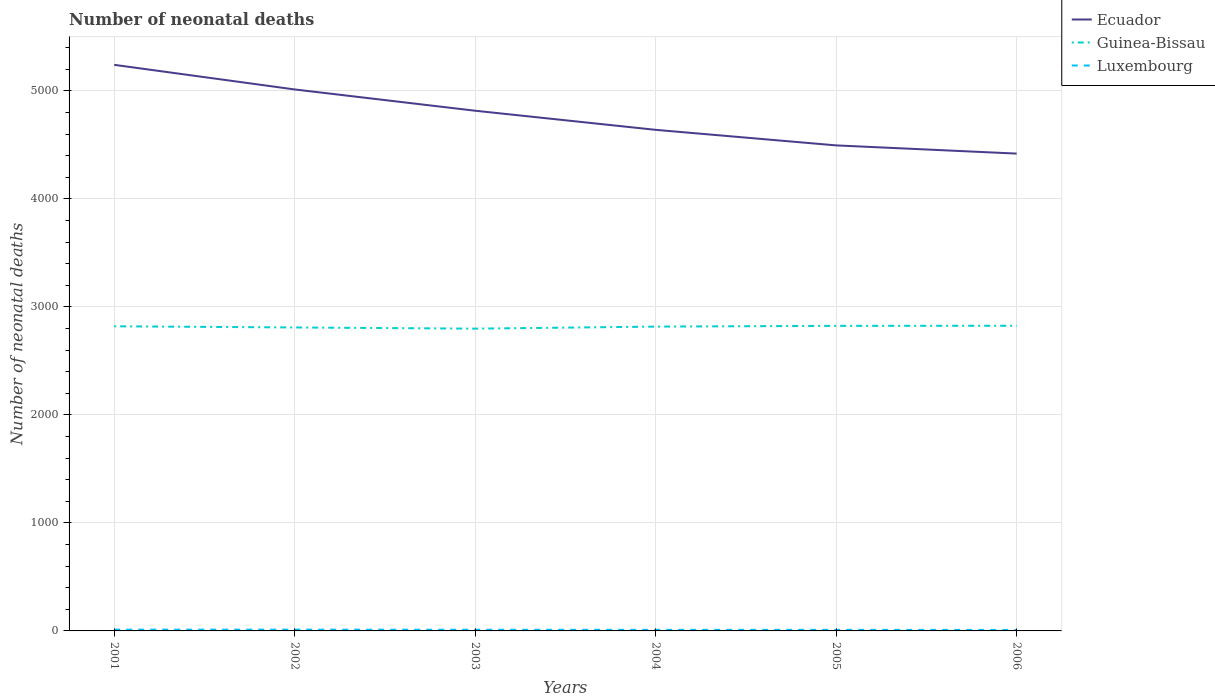Across all years, what is the maximum number of neonatal deaths in in Guinea-Bissau?
Keep it short and to the point. 2799. What is the total number of neonatal deaths in in Guinea-Bissau in the graph?
Your response must be concise. 3. What is the difference between the highest and the second highest number of neonatal deaths in in Guinea-Bissau?
Keep it short and to the point. 27. What is the difference between the highest and the lowest number of neonatal deaths in in Ecuador?
Your answer should be compact. 3. How many years are there in the graph?
Your answer should be compact. 6. What is the difference between two consecutive major ticks on the Y-axis?
Provide a succinct answer. 1000. Does the graph contain grids?
Provide a succinct answer. Yes. How many legend labels are there?
Provide a short and direct response. 3. How are the legend labels stacked?
Provide a succinct answer. Vertical. What is the title of the graph?
Your answer should be very brief. Number of neonatal deaths. What is the label or title of the X-axis?
Ensure brevity in your answer.  Years. What is the label or title of the Y-axis?
Your answer should be compact. Number of neonatal deaths. What is the Number of neonatal deaths in Ecuador in 2001?
Offer a very short reply. 5242. What is the Number of neonatal deaths in Guinea-Bissau in 2001?
Your answer should be very brief. 2821. What is the Number of neonatal deaths in Luxembourg in 2001?
Your response must be concise. 12. What is the Number of neonatal deaths of Ecuador in 2002?
Provide a short and direct response. 5014. What is the Number of neonatal deaths of Guinea-Bissau in 2002?
Provide a short and direct response. 2810. What is the Number of neonatal deaths of Ecuador in 2003?
Keep it short and to the point. 4817. What is the Number of neonatal deaths of Guinea-Bissau in 2003?
Keep it short and to the point. 2799. What is the Number of neonatal deaths of Luxembourg in 2003?
Keep it short and to the point. 11. What is the Number of neonatal deaths in Ecuador in 2004?
Your answer should be compact. 4640. What is the Number of neonatal deaths in Guinea-Bissau in 2004?
Keep it short and to the point. 2818. What is the Number of neonatal deaths of Luxembourg in 2004?
Provide a short and direct response. 10. What is the Number of neonatal deaths in Ecuador in 2005?
Provide a succinct answer. 4496. What is the Number of neonatal deaths in Guinea-Bissau in 2005?
Give a very brief answer. 2825. What is the Number of neonatal deaths in Luxembourg in 2005?
Offer a very short reply. 10. What is the Number of neonatal deaths of Ecuador in 2006?
Keep it short and to the point. 4420. What is the Number of neonatal deaths in Guinea-Bissau in 2006?
Give a very brief answer. 2826. What is the Number of neonatal deaths of Luxembourg in 2006?
Offer a terse response. 9. Across all years, what is the maximum Number of neonatal deaths in Ecuador?
Give a very brief answer. 5242. Across all years, what is the maximum Number of neonatal deaths in Guinea-Bissau?
Your response must be concise. 2826. Across all years, what is the maximum Number of neonatal deaths of Luxembourg?
Keep it short and to the point. 12. Across all years, what is the minimum Number of neonatal deaths in Ecuador?
Ensure brevity in your answer.  4420. Across all years, what is the minimum Number of neonatal deaths in Guinea-Bissau?
Your response must be concise. 2799. What is the total Number of neonatal deaths of Ecuador in the graph?
Provide a short and direct response. 2.86e+04. What is the total Number of neonatal deaths in Guinea-Bissau in the graph?
Make the answer very short. 1.69e+04. What is the difference between the Number of neonatal deaths in Ecuador in 2001 and that in 2002?
Offer a very short reply. 228. What is the difference between the Number of neonatal deaths in Guinea-Bissau in 2001 and that in 2002?
Your answer should be very brief. 11. What is the difference between the Number of neonatal deaths of Ecuador in 2001 and that in 2003?
Make the answer very short. 425. What is the difference between the Number of neonatal deaths in Guinea-Bissau in 2001 and that in 2003?
Offer a terse response. 22. What is the difference between the Number of neonatal deaths of Ecuador in 2001 and that in 2004?
Provide a succinct answer. 602. What is the difference between the Number of neonatal deaths of Guinea-Bissau in 2001 and that in 2004?
Your response must be concise. 3. What is the difference between the Number of neonatal deaths in Luxembourg in 2001 and that in 2004?
Offer a terse response. 2. What is the difference between the Number of neonatal deaths in Ecuador in 2001 and that in 2005?
Your response must be concise. 746. What is the difference between the Number of neonatal deaths of Luxembourg in 2001 and that in 2005?
Offer a terse response. 2. What is the difference between the Number of neonatal deaths of Ecuador in 2001 and that in 2006?
Ensure brevity in your answer.  822. What is the difference between the Number of neonatal deaths of Luxembourg in 2001 and that in 2006?
Make the answer very short. 3. What is the difference between the Number of neonatal deaths in Ecuador in 2002 and that in 2003?
Make the answer very short. 197. What is the difference between the Number of neonatal deaths in Guinea-Bissau in 2002 and that in 2003?
Give a very brief answer. 11. What is the difference between the Number of neonatal deaths of Luxembourg in 2002 and that in 2003?
Give a very brief answer. 1. What is the difference between the Number of neonatal deaths in Ecuador in 2002 and that in 2004?
Provide a succinct answer. 374. What is the difference between the Number of neonatal deaths in Ecuador in 2002 and that in 2005?
Your answer should be compact. 518. What is the difference between the Number of neonatal deaths in Guinea-Bissau in 2002 and that in 2005?
Keep it short and to the point. -15. What is the difference between the Number of neonatal deaths in Luxembourg in 2002 and that in 2005?
Your answer should be very brief. 2. What is the difference between the Number of neonatal deaths of Ecuador in 2002 and that in 2006?
Your answer should be very brief. 594. What is the difference between the Number of neonatal deaths in Ecuador in 2003 and that in 2004?
Your response must be concise. 177. What is the difference between the Number of neonatal deaths of Ecuador in 2003 and that in 2005?
Offer a terse response. 321. What is the difference between the Number of neonatal deaths of Guinea-Bissau in 2003 and that in 2005?
Make the answer very short. -26. What is the difference between the Number of neonatal deaths of Luxembourg in 2003 and that in 2005?
Your answer should be compact. 1. What is the difference between the Number of neonatal deaths of Ecuador in 2003 and that in 2006?
Your response must be concise. 397. What is the difference between the Number of neonatal deaths in Luxembourg in 2003 and that in 2006?
Provide a succinct answer. 2. What is the difference between the Number of neonatal deaths of Ecuador in 2004 and that in 2005?
Ensure brevity in your answer.  144. What is the difference between the Number of neonatal deaths in Luxembourg in 2004 and that in 2005?
Keep it short and to the point. 0. What is the difference between the Number of neonatal deaths of Ecuador in 2004 and that in 2006?
Provide a succinct answer. 220. What is the difference between the Number of neonatal deaths of Guinea-Bissau in 2005 and that in 2006?
Offer a very short reply. -1. What is the difference between the Number of neonatal deaths in Ecuador in 2001 and the Number of neonatal deaths in Guinea-Bissau in 2002?
Provide a short and direct response. 2432. What is the difference between the Number of neonatal deaths of Ecuador in 2001 and the Number of neonatal deaths of Luxembourg in 2002?
Your response must be concise. 5230. What is the difference between the Number of neonatal deaths of Guinea-Bissau in 2001 and the Number of neonatal deaths of Luxembourg in 2002?
Give a very brief answer. 2809. What is the difference between the Number of neonatal deaths of Ecuador in 2001 and the Number of neonatal deaths of Guinea-Bissau in 2003?
Make the answer very short. 2443. What is the difference between the Number of neonatal deaths in Ecuador in 2001 and the Number of neonatal deaths in Luxembourg in 2003?
Provide a short and direct response. 5231. What is the difference between the Number of neonatal deaths of Guinea-Bissau in 2001 and the Number of neonatal deaths of Luxembourg in 2003?
Give a very brief answer. 2810. What is the difference between the Number of neonatal deaths in Ecuador in 2001 and the Number of neonatal deaths in Guinea-Bissau in 2004?
Offer a very short reply. 2424. What is the difference between the Number of neonatal deaths of Ecuador in 2001 and the Number of neonatal deaths of Luxembourg in 2004?
Make the answer very short. 5232. What is the difference between the Number of neonatal deaths in Guinea-Bissau in 2001 and the Number of neonatal deaths in Luxembourg in 2004?
Ensure brevity in your answer.  2811. What is the difference between the Number of neonatal deaths in Ecuador in 2001 and the Number of neonatal deaths in Guinea-Bissau in 2005?
Your answer should be very brief. 2417. What is the difference between the Number of neonatal deaths in Ecuador in 2001 and the Number of neonatal deaths in Luxembourg in 2005?
Ensure brevity in your answer.  5232. What is the difference between the Number of neonatal deaths in Guinea-Bissau in 2001 and the Number of neonatal deaths in Luxembourg in 2005?
Your answer should be compact. 2811. What is the difference between the Number of neonatal deaths of Ecuador in 2001 and the Number of neonatal deaths of Guinea-Bissau in 2006?
Provide a short and direct response. 2416. What is the difference between the Number of neonatal deaths of Ecuador in 2001 and the Number of neonatal deaths of Luxembourg in 2006?
Your response must be concise. 5233. What is the difference between the Number of neonatal deaths in Guinea-Bissau in 2001 and the Number of neonatal deaths in Luxembourg in 2006?
Your response must be concise. 2812. What is the difference between the Number of neonatal deaths of Ecuador in 2002 and the Number of neonatal deaths of Guinea-Bissau in 2003?
Make the answer very short. 2215. What is the difference between the Number of neonatal deaths in Ecuador in 2002 and the Number of neonatal deaths in Luxembourg in 2003?
Your answer should be compact. 5003. What is the difference between the Number of neonatal deaths of Guinea-Bissau in 2002 and the Number of neonatal deaths of Luxembourg in 2003?
Make the answer very short. 2799. What is the difference between the Number of neonatal deaths in Ecuador in 2002 and the Number of neonatal deaths in Guinea-Bissau in 2004?
Your response must be concise. 2196. What is the difference between the Number of neonatal deaths of Ecuador in 2002 and the Number of neonatal deaths of Luxembourg in 2004?
Make the answer very short. 5004. What is the difference between the Number of neonatal deaths of Guinea-Bissau in 2002 and the Number of neonatal deaths of Luxembourg in 2004?
Ensure brevity in your answer.  2800. What is the difference between the Number of neonatal deaths of Ecuador in 2002 and the Number of neonatal deaths of Guinea-Bissau in 2005?
Provide a succinct answer. 2189. What is the difference between the Number of neonatal deaths of Ecuador in 2002 and the Number of neonatal deaths of Luxembourg in 2005?
Your answer should be compact. 5004. What is the difference between the Number of neonatal deaths in Guinea-Bissau in 2002 and the Number of neonatal deaths in Luxembourg in 2005?
Ensure brevity in your answer.  2800. What is the difference between the Number of neonatal deaths in Ecuador in 2002 and the Number of neonatal deaths in Guinea-Bissau in 2006?
Offer a terse response. 2188. What is the difference between the Number of neonatal deaths in Ecuador in 2002 and the Number of neonatal deaths in Luxembourg in 2006?
Provide a succinct answer. 5005. What is the difference between the Number of neonatal deaths of Guinea-Bissau in 2002 and the Number of neonatal deaths of Luxembourg in 2006?
Ensure brevity in your answer.  2801. What is the difference between the Number of neonatal deaths in Ecuador in 2003 and the Number of neonatal deaths in Guinea-Bissau in 2004?
Keep it short and to the point. 1999. What is the difference between the Number of neonatal deaths of Ecuador in 2003 and the Number of neonatal deaths of Luxembourg in 2004?
Make the answer very short. 4807. What is the difference between the Number of neonatal deaths in Guinea-Bissau in 2003 and the Number of neonatal deaths in Luxembourg in 2004?
Offer a terse response. 2789. What is the difference between the Number of neonatal deaths of Ecuador in 2003 and the Number of neonatal deaths of Guinea-Bissau in 2005?
Your response must be concise. 1992. What is the difference between the Number of neonatal deaths of Ecuador in 2003 and the Number of neonatal deaths of Luxembourg in 2005?
Provide a succinct answer. 4807. What is the difference between the Number of neonatal deaths in Guinea-Bissau in 2003 and the Number of neonatal deaths in Luxembourg in 2005?
Ensure brevity in your answer.  2789. What is the difference between the Number of neonatal deaths of Ecuador in 2003 and the Number of neonatal deaths of Guinea-Bissau in 2006?
Provide a succinct answer. 1991. What is the difference between the Number of neonatal deaths in Ecuador in 2003 and the Number of neonatal deaths in Luxembourg in 2006?
Your response must be concise. 4808. What is the difference between the Number of neonatal deaths in Guinea-Bissau in 2003 and the Number of neonatal deaths in Luxembourg in 2006?
Offer a very short reply. 2790. What is the difference between the Number of neonatal deaths in Ecuador in 2004 and the Number of neonatal deaths in Guinea-Bissau in 2005?
Your response must be concise. 1815. What is the difference between the Number of neonatal deaths of Ecuador in 2004 and the Number of neonatal deaths of Luxembourg in 2005?
Ensure brevity in your answer.  4630. What is the difference between the Number of neonatal deaths of Guinea-Bissau in 2004 and the Number of neonatal deaths of Luxembourg in 2005?
Give a very brief answer. 2808. What is the difference between the Number of neonatal deaths of Ecuador in 2004 and the Number of neonatal deaths of Guinea-Bissau in 2006?
Give a very brief answer. 1814. What is the difference between the Number of neonatal deaths in Ecuador in 2004 and the Number of neonatal deaths in Luxembourg in 2006?
Your answer should be compact. 4631. What is the difference between the Number of neonatal deaths in Guinea-Bissau in 2004 and the Number of neonatal deaths in Luxembourg in 2006?
Your answer should be very brief. 2809. What is the difference between the Number of neonatal deaths of Ecuador in 2005 and the Number of neonatal deaths of Guinea-Bissau in 2006?
Your answer should be very brief. 1670. What is the difference between the Number of neonatal deaths in Ecuador in 2005 and the Number of neonatal deaths in Luxembourg in 2006?
Ensure brevity in your answer.  4487. What is the difference between the Number of neonatal deaths of Guinea-Bissau in 2005 and the Number of neonatal deaths of Luxembourg in 2006?
Make the answer very short. 2816. What is the average Number of neonatal deaths of Ecuador per year?
Your answer should be very brief. 4771.5. What is the average Number of neonatal deaths of Guinea-Bissau per year?
Your answer should be very brief. 2816.5. What is the average Number of neonatal deaths of Luxembourg per year?
Give a very brief answer. 10.67. In the year 2001, what is the difference between the Number of neonatal deaths of Ecuador and Number of neonatal deaths of Guinea-Bissau?
Keep it short and to the point. 2421. In the year 2001, what is the difference between the Number of neonatal deaths of Ecuador and Number of neonatal deaths of Luxembourg?
Provide a succinct answer. 5230. In the year 2001, what is the difference between the Number of neonatal deaths of Guinea-Bissau and Number of neonatal deaths of Luxembourg?
Your response must be concise. 2809. In the year 2002, what is the difference between the Number of neonatal deaths of Ecuador and Number of neonatal deaths of Guinea-Bissau?
Your answer should be compact. 2204. In the year 2002, what is the difference between the Number of neonatal deaths of Ecuador and Number of neonatal deaths of Luxembourg?
Keep it short and to the point. 5002. In the year 2002, what is the difference between the Number of neonatal deaths of Guinea-Bissau and Number of neonatal deaths of Luxembourg?
Your answer should be very brief. 2798. In the year 2003, what is the difference between the Number of neonatal deaths in Ecuador and Number of neonatal deaths in Guinea-Bissau?
Keep it short and to the point. 2018. In the year 2003, what is the difference between the Number of neonatal deaths in Ecuador and Number of neonatal deaths in Luxembourg?
Your answer should be very brief. 4806. In the year 2003, what is the difference between the Number of neonatal deaths in Guinea-Bissau and Number of neonatal deaths in Luxembourg?
Your answer should be very brief. 2788. In the year 2004, what is the difference between the Number of neonatal deaths of Ecuador and Number of neonatal deaths of Guinea-Bissau?
Your answer should be compact. 1822. In the year 2004, what is the difference between the Number of neonatal deaths in Ecuador and Number of neonatal deaths in Luxembourg?
Your response must be concise. 4630. In the year 2004, what is the difference between the Number of neonatal deaths of Guinea-Bissau and Number of neonatal deaths of Luxembourg?
Give a very brief answer. 2808. In the year 2005, what is the difference between the Number of neonatal deaths in Ecuador and Number of neonatal deaths in Guinea-Bissau?
Provide a succinct answer. 1671. In the year 2005, what is the difference between the Number of neonatal deaths of Ecuador and Number of neonatal deaths of Luxembourg?
Make the answer very short. 4486. In the year 2005, what is the difference between the Number of neonatal deaths in Guinea-Bissau and Number of neonatal deaths in Luxembourg?
Keep it short and to the point. 2815. In the year 2006, what is the difference between the Number of neonatal deaths of Ecuador and Number of neonatal deaths of Guinea-Bissau?
Your answer should be compact. 1594. In the year 2006, what is the difference between the Number of neonatal deaths of Ecuador and Number of neonatal deaths of Luxembourg?
Your response must be concise. 4411. In the year 2006, what is the difference between the Number of neonatal deaths of Guinea-Bissau and Number of neonatal deaths of Luxembourg?
Your answer should be very brief. 2817. What is the ratio of the Number of neonatal deaths of Ecuador in 2001 to that in 2002?
Ensure brevity in your answer.  1.05. What is the ratio of the Number of neonatal deaths in Guinea-Bissau in 2001 to that in 2002?
Your answer should be compact. 1. What is the ratio of the Number of neonatal deaths in Luxembourg in 2001 to that in 2002?
Provide a short and direct response. 1. What is the ratio of the Number of neonatal deaths in Ecuador in 2001 to that in 2003?
Ensure brevity in your answer.  1.09. What is the ratio of the Number of neonatal deaths of Guinea-Bissau in 2001 to that in 2003?
Your answer should be very brief. 1.01. What is the ratio of the Number of neonatal deaths of Luxembourg in 2001 to that in 2003?
Provide a short and direct response. 1.09. What is the ratio of the Number of neonatal deaths in Ecuador in 2001 to that in 2004?
Make the answer very short. 1.13. What is the ratio of the Number of neonatal deaths in Guinea-Bissau in 2001 to that in 2004?
Your response must be concise. 1. What is the ratio of the Number of neonatal deaths in Luxembourg in 2001 to that in 2004?
Make the answer very short. 1.2. What is the ratio of the Number of neonatal deaths in Ecuador in 2001 to that in 2005?
Offer a very short reply. 1.17. What is the ratio of the Number of neonatal deaths in Guinea-Bissau in 2001 to that in 2005?
Your answer should be compact. 1. What is the ratio of the Number of neonatal deaths of Luxembourg in 2001 to that in 2005?
Offer a terse response. 1.2. What is the ratio of the Number of neonatal deaths in Ecuador in 2001 to that in 2006?
Provide a succinct answer. 1.19. What is the ratio of the Number of neonatal deaths in Luxembourg in 2001 to that in 2006?
Your response must be concise. 1.33. What is the ratio of the Number of neonatal deaths in Ecuador in 2002 to that in 2003?
Make the answer very short. 1.04. What is the ratio of the Number of neonatal deaths of Ecuador in 2002 to that in 2004?
Your answer should be compact. 1.08. What is the ratio of the Number of neonatal deaths in Guinea-Bissau in 2002 to that in 2004?
Ensure brevity in your answer.  1. What is the ratio of the Number of neonatal deaths in Ecuador in 2002 to that in 2005?
Your answer should be very brief. 1.12. What is the ratio of the Number of neonatal deaths in Ecuador in 2002 to that in 2006?
Ensure brevity in your answer.  1.13. What is the ratio of the Number of neonatal deaths in Luxembourg in 2002 to that in 2006?
Offer a terse response. 1.33. What is the ratio of the Number of neonatal deaths in Ecuador in 2003 to that in 2004?
Keep it short and to the point. 1.04. What is the ratio of the Number of neonatal deaths of Ecuador in 2003 to that in 2005?
Your answer should be compact. 1.07. What is the ratio of the Number of neonatal deaths of Luxembourg in 2003 to that in 2005?
Keep it short and to the point. 1.1. What is the ratio of the Number of neonatal deaths of Ecuador in 2003 to that in 2006?
Your answer should be compact. 1.09. What is the ratio of the Number of neonatal deaths of Guinea-Bissau in 2003 to that in 2006?
Make the answer very short. 0.99. What is the ratio of the Number of neonatal deaths of Luxembourg in 2003 to that in 2006?
Provide a short and direct response. 1.22. What is the ratio of the Number of neonatal deaths of Ecuador in 2004 to that in 2005?
Your answer should be very brief. 1.03. What is the ratio of the Number of neonatal deaths of Guinea-Bissau in 2004 to that in 2005?
Your response must be concise. 1. What is the ratio of the Number of neonatal deaths of Luxembourg in 2004 to that in 2005?
Your answer should be very brief. 1. What is the ratio of the Number of neonatal deaths of Ecuador in 2004 to that in 2006?
Give a very brief answer. 1.05. What is the ratio of the Number of neonatal deaths in Luxembourg in 2004 to that in 2006?
Make the answer very short. 1.11. What is the ratio of the Number of neonatal deaths of Ecuador in 2005 to that in 2006?
Provide a succinct answer. 1.02. What is the difference between the highest and the second highest Number of neonatal deaths in Ecuador?
Your answer should be compact. 228. What is the difference between the highest and the second highest Number of neonatal deaths in Guinea-Bissau?
Your answer should be very brief. 1. What is the difference between the highest and the second highest Number of neonatal deaths in Luxembourg?
Provide a short and direct response. 0. What is the difference between the highest and the lowest Number of neonatal deaths in Ecuador?
Your answer should be very brief. 822. What is the difference between the highest and the lowest Number of neonatal deaths of Guinea-Bissau?
Your answer should be very brief. 27. 